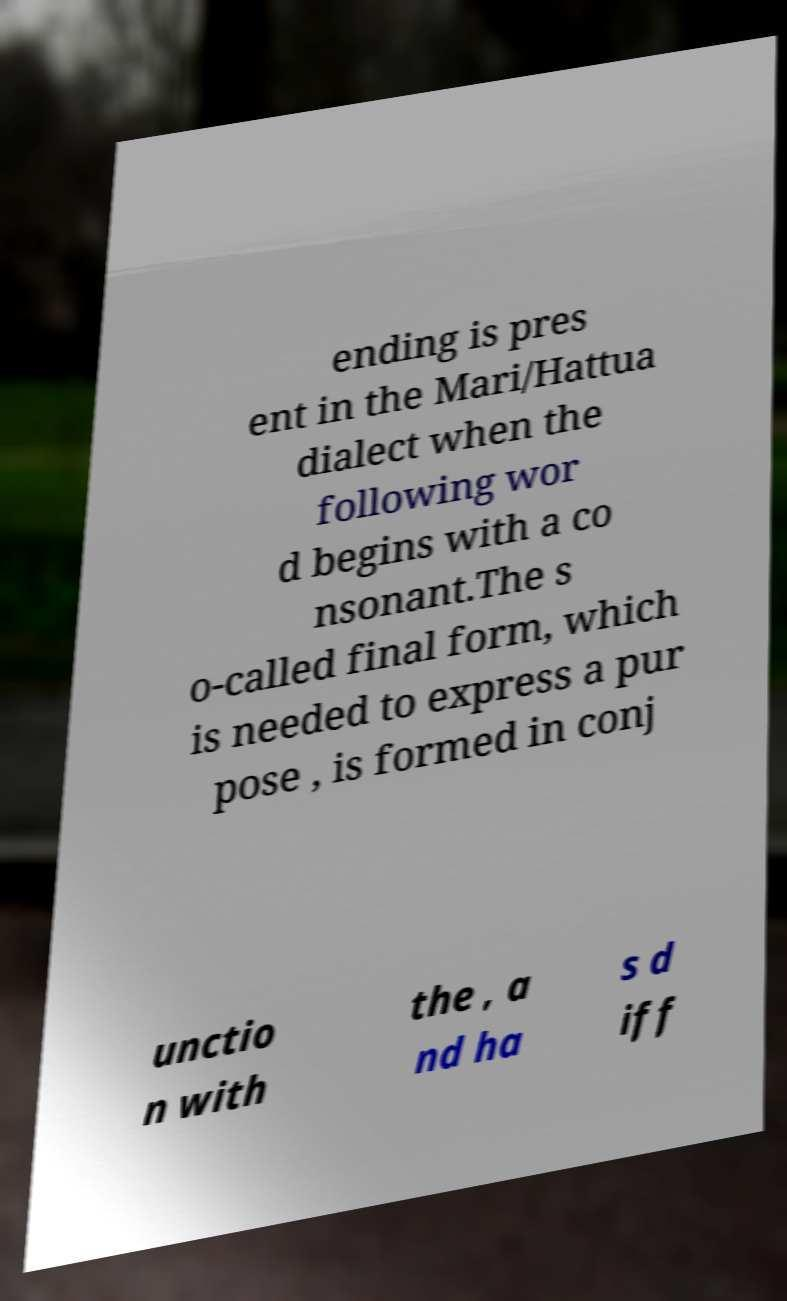Can you read and provide the text displayed in the image?This photo seems to have some interesting text. Can you extract and type it out for me? ending is pres ent in the Mari/Hattua dialect when the following wor d begins with a co nsonant.The s o-called final form, which is needed to express a pur pose , is formed in conj unctio n with the , a nd ha s d iff 